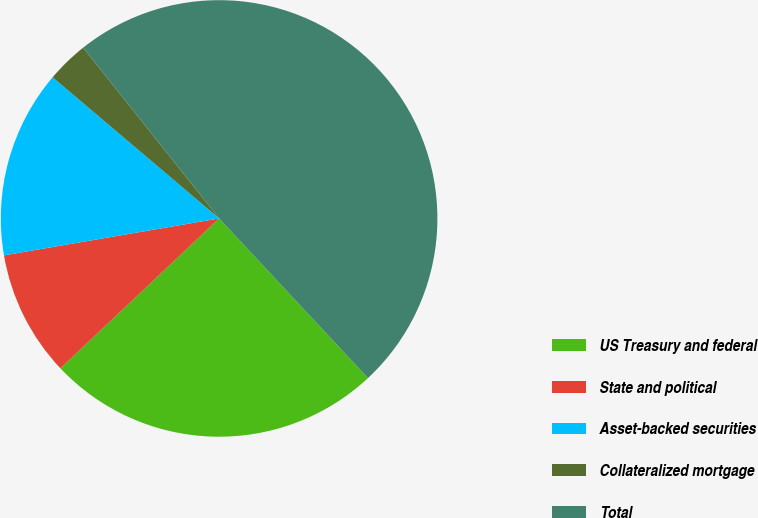Convert chart to OTSL. <chart><loc_0><loc_0><loc_500><loc_500><pie_chart><fcel>US Treasury and federal<fcel>State and political<fcel>Asset-backed securities<fcel>Collateralized mortgage<fcel>Total<nl><fcel>24.9%<fcel>9.34%<fcel>13.9%<fcel>3.11%<fcel>48.76%<nl></chart> 